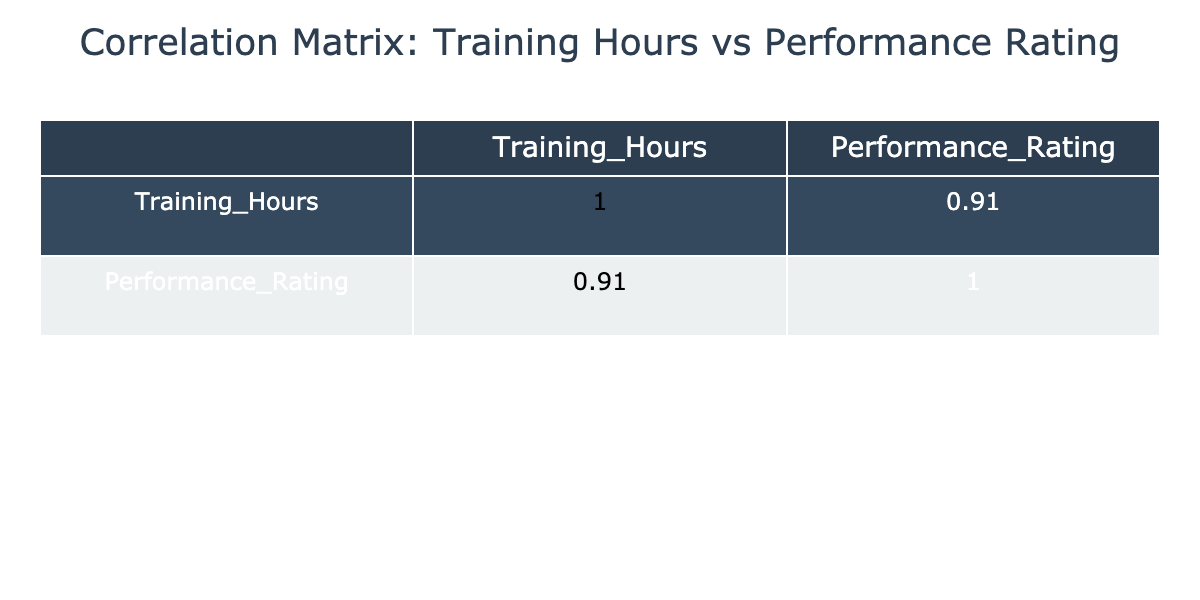What is the correlation coefficient between Training Hours and Performance Rating? The correlation matrix shows the relationship between Training Hours and Performance Rating. The correlation coefficient is the value at the intersection of the Training Hours row and Performance Rating column. It is approximately 0.9, indicating a strong positive correlation.
Answer: 0.9 Which pilot has the highest Performance Rating? By examining the Performance Rating column, Emily Johnson has the highest rating of 90.
Answer: 90 What are the Training Hours of the pilot with the lowest Performance Rating? Looking at the Performance Rating column, Daniel Hall has the lowest rating of 78. In the corresponding Training Hours column, Daniel Hall has 130 hours of training.
Answer: 130 What is the average Performance Rating for pilots with more than 150 Training Hours? The pilots with more than 150 hours are John Smith, Emily Johnson, James Martin, Jessica Lee, Sophia Wright, and Charles Harris. Their ratings are 85, 90, 91, 93, 89, and 85, respectively. Summing these together gives 85 + 90 + 91 + 93 + 89 + 85 = 513. Dividing this by 6 (the number of pilots) gives an average of 85.5.
Answer: 85.5 Is there a pilot whose training hours exceed 200? By inspecting the Training Hours column, there's no pilot with training hours exceeding 200; Jessica Lee has 210 hours, which means the statement is true.
Answer: Yes What is the difference in Performance Rating between the pilot with the most training hours and the pilot with the least training hours? The pilot with the most training hours is Jessica Lee with 210 hours and a Performance Rating of 93. The pilot with the least training hours is Karen Clark with 110 hours and a Performance Rating of 75. The difference in their performances is 93 - 75 = 18.
Answer: 18 How many pilots have a Performance Rating of 85 or higher? Inspecting the Performance Rating column, we find the ratings of John Smith, Emily Johnson, Sarah Williams, James Martin, Jessica Lee, Sophia Wright, Charles Harris, Linda Robinson, and Robert Walker. In total, there are 9 pilots with a rating of 85 or higher.
Answer: 9 What is the Training Hours of the average-rated pilot (Performance Rating of 85)? The pilots with a Performance Rating of 85 are John Smith and Charles Harris. Their Training Hours are 150 and 170, respectively. To find the average Training Hours, add them up: 150 + 170 = 320, then divide by 2: 320 / 2 = 160.
Answer: 160 Are there any pilots with Training Hours less than 120? When examining the Training Hours column, the pilot with the least hours is Karen Clark at 110. Therefore, there are pilots with less than 120 hours.
Answer: Yes 